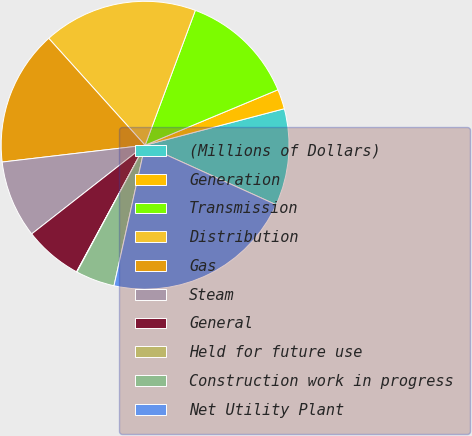Convert chart to OTSL. <chart><loc_0><loc_0><loc_500><loc_500><pie_chart><fcel>(Millions of Dollars)<fcel>Generation<fcel>Transmission<fcel>Distribution<fcel>Gas<fcel>Steam<fcel>General<fcel>Held for future use<fcel>Construction work in progress<fcel>Net Utility Plant<nl><fcel>10.87%<fcel>2.21%<fcel>13.03%<fcel>17.35%<fcel>15.19%<fcel>8.7%<fcel>6.54%<fcel>0.05%<fcel>4.38%<fcel>21.68%<nl></chart> 